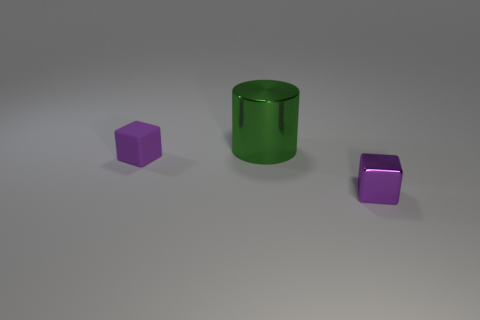Is there any other thing that is the same size as the cylinder?
Provide a succinct answer. No. Is there anything else that has the same material as the big cylinder?
Provide a short and direct response. Yes. Does the purple object that is on the left side of the large object have the same shape as the big green object?
Your answer should be compact. No. Is the large green metallic object the same shape as the tiny matte thing?
Give a very brief answer. No. Is there another big brown thing that has the same shape as the rubber object?
Keep it short and to the point. No. There is a thing behind the purple cube to the left of the big green cylinder; what shape is it?
Your response must be concise. Cylinder. There is a tiny thing to the left of the purple metal cube; what color is it?
Offer a very short reply. Purple. There is another object that is the same material as the green object; what size is it?
Keep it short and to the point. Small. There is a purple shiny object that is the same shape as the small matte object; what is its size?
Keep it short and to the point. Small. Are there any tiny shiny blocks?
Your answer should be very brief. Yes. 